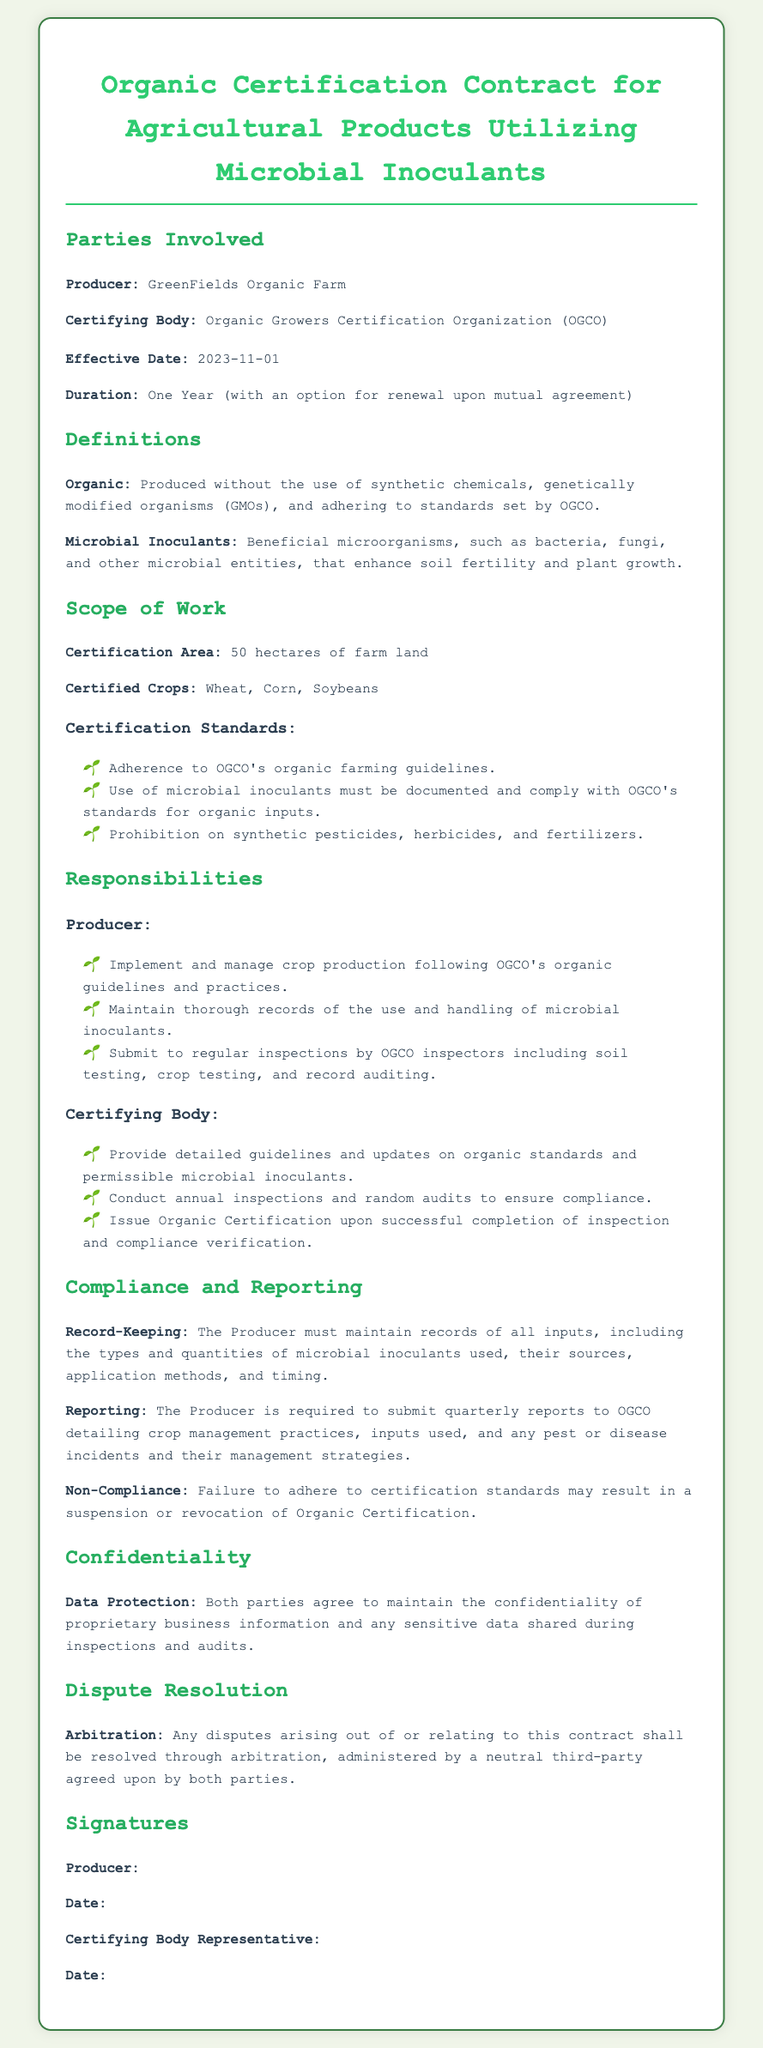What is the Producer's name? The Producer is identified as GreenFields Organic Farm in the document.
Answer: GreenFields Organic Farm What is the effective date of the contract? The effective date is explicitly stated in the document as November 1, 2023.
Answer: 2023-11-01 How many hectares are covered under the certification area? The certification area is mentioned as a specific size in the document, which is 50 hectares.
Answer: 50 hectares What type of crops are certified under this contract? The document lists specific crops that are certified, including Wheat, Corn, and Soybeans.
Answer: Wheat, Corn, Soybeans What is the duration of the contract? The document states the duration of the contract as one year with an option for renewal.
Answer: One Year What is required from the Producer concerning microbial inoculants? The responsibilities section indicates that the Producer must maintain thorough records of microbial inoculants used.
Answer: Maintain thorough records What happens in case of non-compliance? The consequences of non-compliance are clearly defined in the compliance section, stating a suspension or revocation of certification.
Answer: Suspension or revocation What is the process for dispute resolution mentioned in the contract? The contract specifies that disputes shall be resolved through arbitration by an agreed neutral third-party.
Answer: Arbitration What type of body is the OGCO? The OGCO is referred to as the certifying body in the context of the contract.
Answer: Certifying Body 